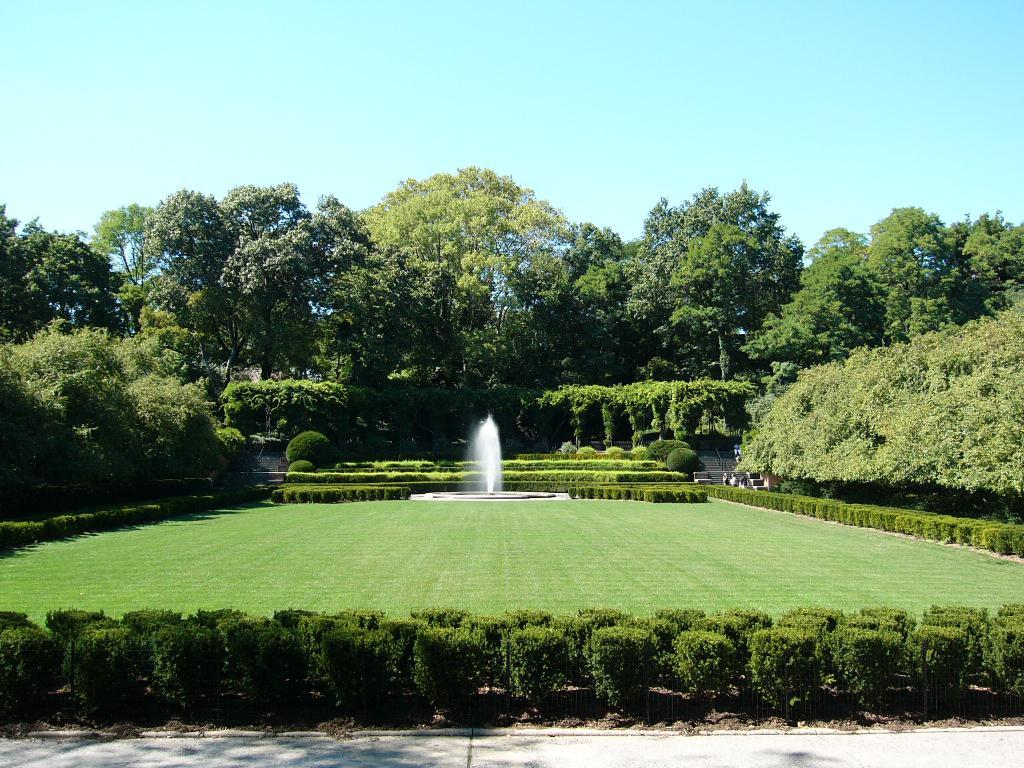What can be seen in the sky in the image? The sky is visible in the image. What type of vegetation is present in the image? There are trees, bushes, and creepers visible in the image. What is a notable feature in the image? There is a fountain in the image. What is the ground like in the image? The ground is visible in the image. Is there a person in the image? Yes, there is a person standing on the ground in the image. What is the size of the mother in the image? There is no mother present in the image, so it is not possible to determine her size. 